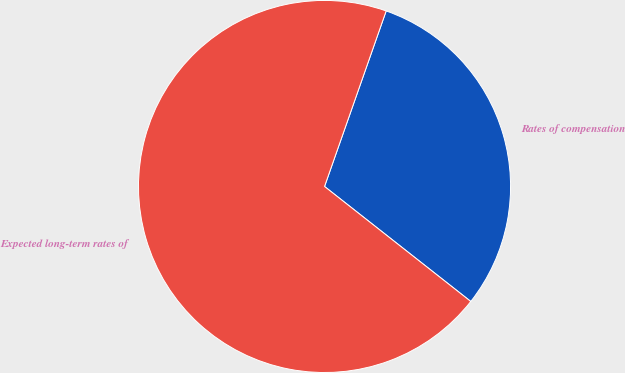<chart> <loc_0><loc_0><loc_500><loc_500><pie_chart><fcel>Rates of compensation<fcel>Expected long-term rates of<nl><fcel>30.23%<fcel>69.77%<nl></chart> 